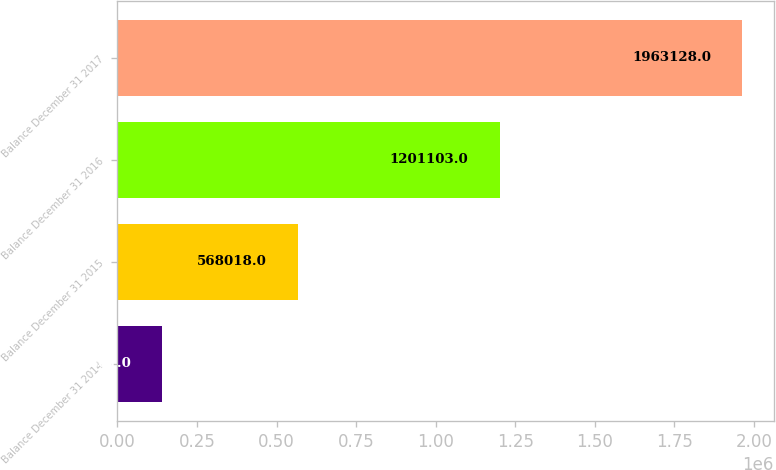<chart> <loc_0><loc_0><loc_500><loc_500><bar_chart><fcel>Balance December 31 2014<fcel>Balance December 31 2015<fcel>Balance December 31 2016<fcel>Balance December 31 2017<nl><fcel>140881<fcel>568018<fcel>1.2011e+06<fcel>1.96313e+06<nl></chart> 